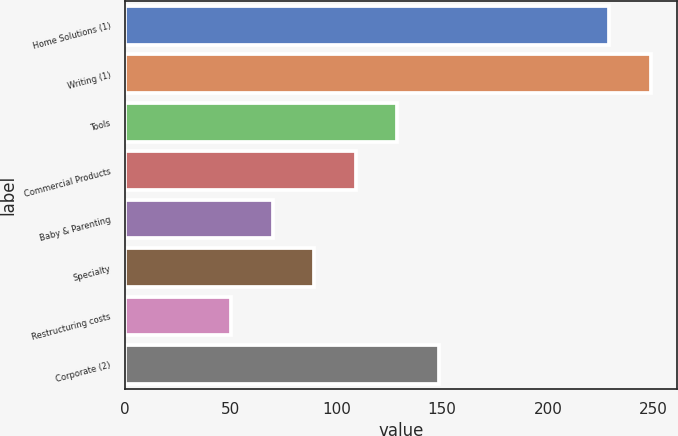Convert chart to OTSL. <chart><loc_0><loc_0><loc_500><loc_500><bar_chart><fcel>Home Solutions (1)<fcel>Writing (1)<fcel>Tools<fcel>Commercial Products<fcel>Baby & Parenting<fcel>Specialty<fcel>Restructuring costs<fcel>Corporate (2)<nl><fcel>228.9<fcel>248.58<fcel>128.82<fcel>109.14<fcel>69.78<fcel>89.46<fcel>50.1<fcel>148.5<nl></chart> 